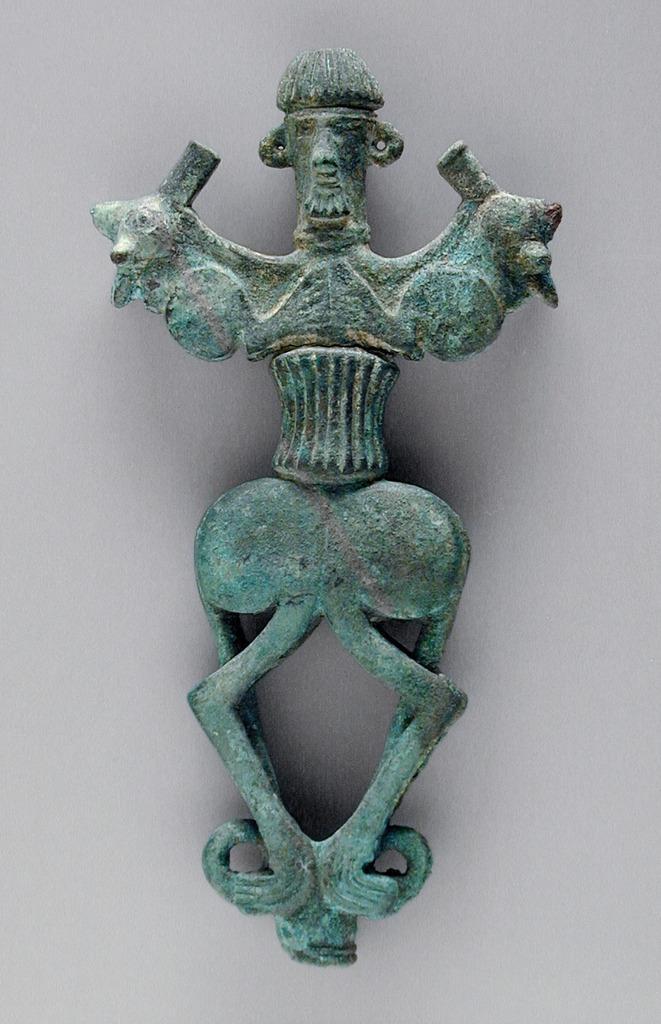Could you give a brief overview of what you see in this image? In this image we can see one bronze standard finial attached to the white wall. 